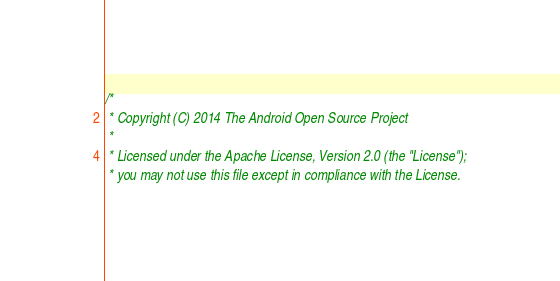<code> <loc_0><loc_0><loc_500><loc_500><_C_>/*
 * Copyright (C) 2014 The Android Open Source Project
 *
 * Licensed under the Apache License, Version 2.0 (the "License");
 * you may not use this file except in compliance with the License.</code> 